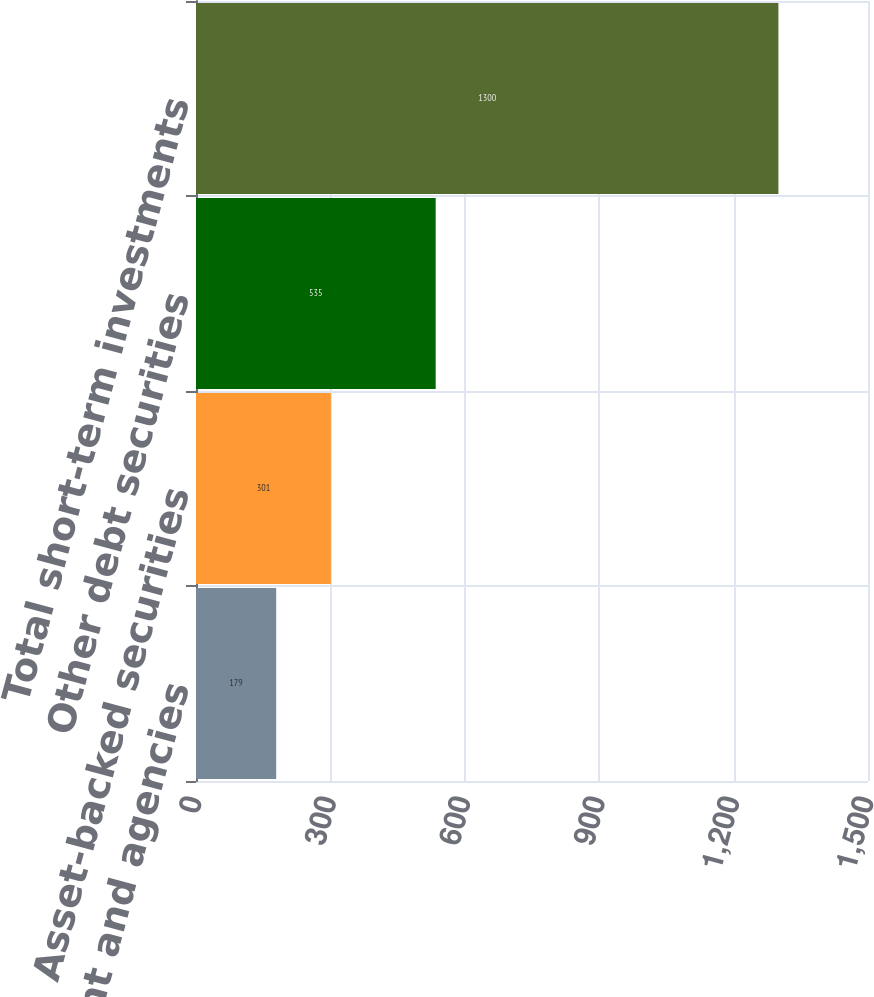<chart> <loc_0><loc_0><loc_500><loc_500><bar_chart><fcel>US government and agencies<fcel>Asset-backed securities<fcel>Other debt securities<fcel>Total short-term investments<nl><fcel>179<fcel>301<fcel>535<fcel>1300<nl></chart> 